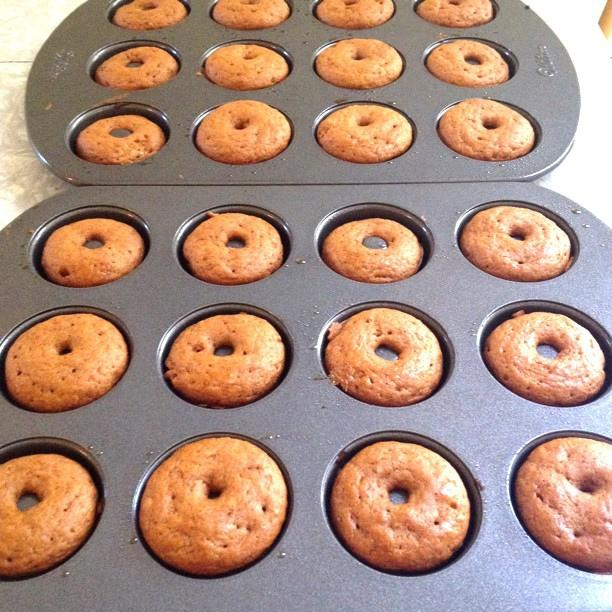What color are the donuts made from this strange pan? Please explain your reasoning. brown. After being baked, the goods turn a golden-brownish color. 